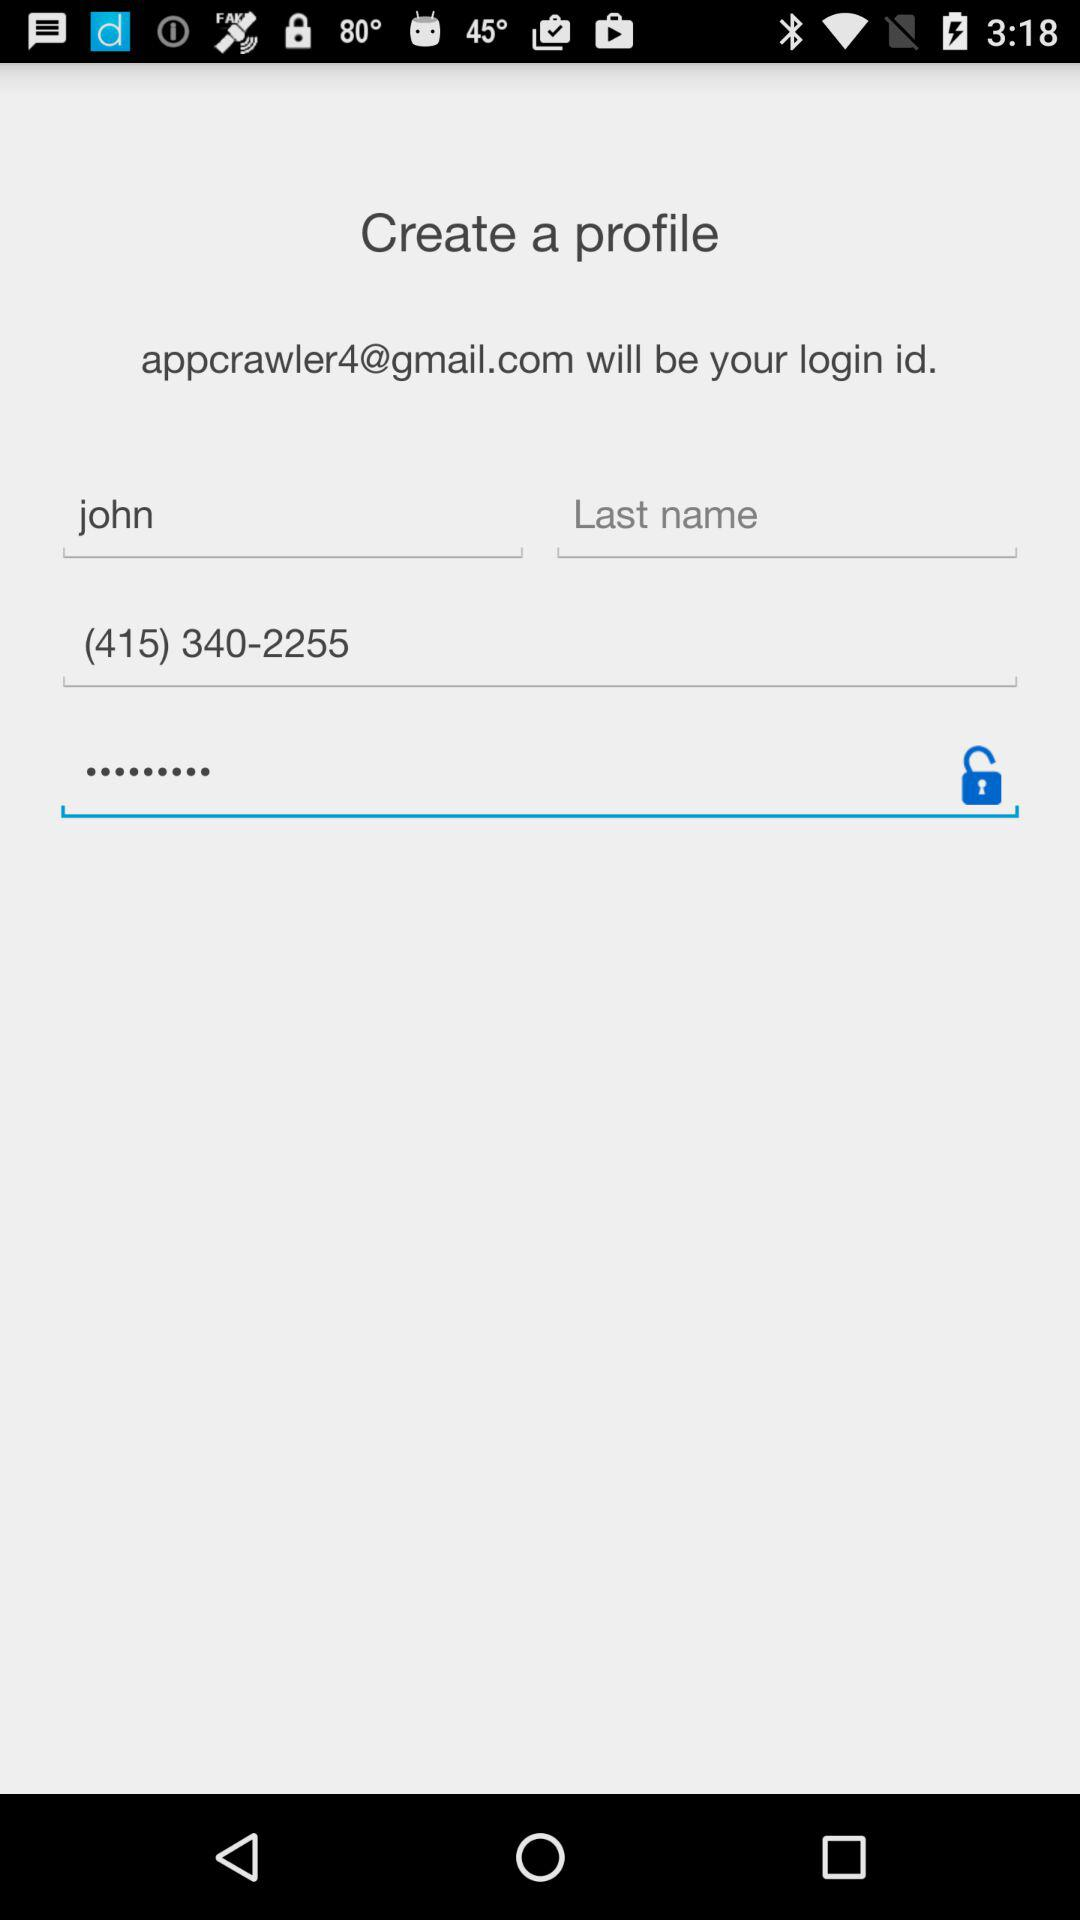What is the phone number? The phone number is (415) 340-2255. 